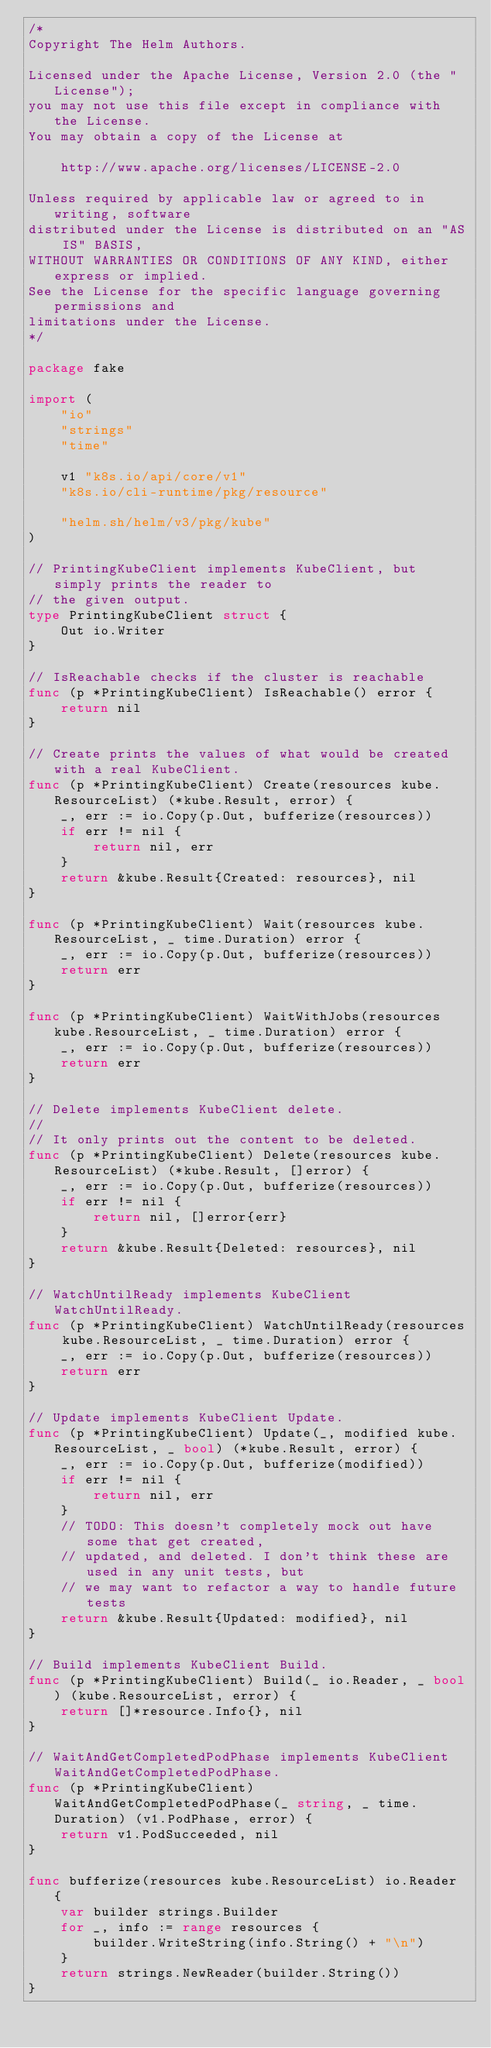<code> <loc_0><loc_0><loc_500><loc_500><_Go_>/*
Copyright The Helm Authors.

Licensed under the Apache License, Version 2.0 (the "License");
you may not use this file except in compliance with the License.
You may obtain a copy of the License at

    http://www.apache.org/licenses/LICENSE-2.0

Unless required by applicable law or agreed to in writing, software
distributed under the License is distributed on an "AS IS" BASIS,
WITHOUT WARRANTIES OR CONDITIONS OF ANY KIND, either express or implied.
See the License for the specific language governing permissions and
limitations under the License.
*/

package fake

import (
	"io"
	"strings"
	"time"

	v1 "k8s.io/api/core/v1"
	"k8s.io/cli-runtime/pkg/resource"

	"helm.sh/helm/v3/pkg/kube"
)

// PrintingKubeClient implements KubeClient, but simply prints the reader to
// the given output.
type PrintingKubeClient struct {
	Out io.Writer
}

// IsReachable checks if the cluster is reachable
func (p *PrintingKubeClient) IsReachable() error {
	return nil
}

// Create prints the values of what would be created with a real KubeClient.
func (p *PrintingKubeClient) Create(resources kube.ResourceList) (*kube.Result, error) {
	_, err := io.Copy(p.Out, bufferize(resources))
	if err != nil {
		return nil, err
	}
	return &kube.Result{Created: resources}, nil
}

func (p *PrintingKubeClient) Wait(resources kube.ResourceList, _ time.Duration) error {
	_, err := io.Copy(p.Out, bufferize(resources))
	return err
}

func (p *PrintingKubeClient) WaitWithJobs(resources kube.ResourceList, _ time.Duration) error {
	_, err := io.Copy(p.Out, bufferize(resources))
	return err
}

// Delete implements KubeClient delete.
//
// It only prints out the content to be deleted.
func (p *PrintingKubeClient) Delete(resources kube.ResourceList) (*kube.Result, []error) {
	_, err := io.Copy(p.Out, bufferize(resources))
	if err != nil {
		return nil, []error{err}
	}
	return &kube.Result{Deleted: resources}, nil
}

// WatchUntilReady implements KubeClient WatchUntilReady.
func (p *PrintingKubeClient) WatchUntilReady(resources kube.ResourceList, _ time.Duration) error {
	_, err := io.Copy(p.Out, bufferize(resources))
	return err
}

// Update implements KubeClient Update.
func (p *PrintingKubeClient) Update(_, modified kube.ResourceList, _ bool) (*kube.Result, error) {
	_, err := io.Copy(p.Out, bufferize(modified))
	if err != nil {
		return nil, err
	}
	// TODO: This doesn't completely mock out have some that get created,
	// updated, and deleted. I don't think these are used in any unit tests, but
	// we may want to refactor a way to handle future tests
	return &kube.Result{Updated: modified}, nil
}

// Build implements KubeClient Build.
func (p *PrintingKubeClient) Build(_ io.Reader, _ bool) (kube.ResourceList, error) {
	return []*resource.Info{}, nil
}

// WaitAndGetCompletedPodPhase implements KubeClient WaitAndGetCompletedPodPhase.
func (p *PrintingKubeClient) WaitAndGetCompletedPodPhase(_ string, _ time.Duration) (v1.PodPhase, error) {
	return v1.PodSucceeded, nil
}

func bufferize(resources kube.ResourceList) io.Reader {
	var builder strings.Builder
	for _, info := range resources {
		builder.WriteString(info.String() + "\n")
	}
	return strings.NewReader(builder.String())
}
</code> 